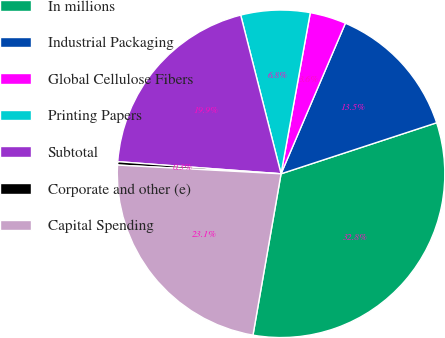Convert chart to OTSL. <chart><loc_0><loc_0><loc_500><loc_500><pie_chart><fcel>In millions<fcel>Industrial Packaging<fcel>Global Cellulose Fibers<fcel>Printing Papers<fcel>Subtotal<fcel>Corporate and other (e)<fcel>Capital Spending<nl><fcel>32.79%<fcel>13.53%<fcel>3.57%<fcel>6.82%<fcel>19.86%<fcel>0.33%<fcel>23.11%<nl></chart> 